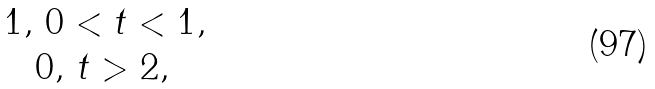Convert formula to latex. <formula><loc_0><loc_0><loc_500><loc_500>\begin{matrix} 1 , \, 0 < t < 1 , \\ 0 , \, t > 2 , \, \end{matrix}</formula> 